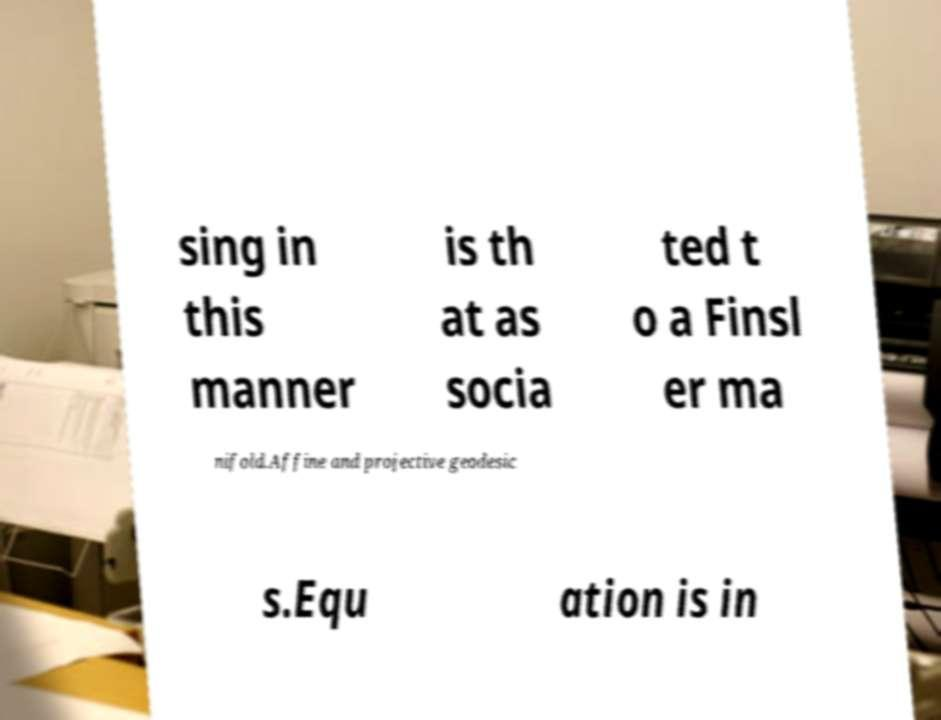Please identify and transcribe the text found in this image. sing in this manner is th at as socia ted t o a Finsl er ma nifold.Affine and projective geodesic s.Equ ation is in 